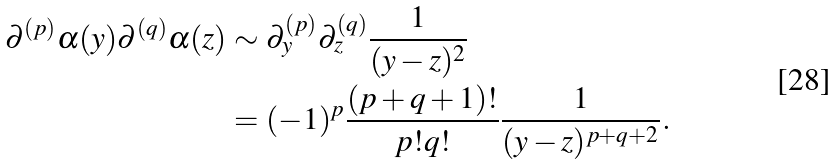<formula> <loc_0><loc_0><loc_500><loc_500>\partial ^ { ( p ) } \alpha ( y ) \partial ^ { ( q ) } \alpha ( z ) & \sim \partial _ { y } ^ { ( p ) } \partial _ { z } ^ { ( q ) } \frac { 1 } { ( y - z ) ^ { 2 } } \\ & = ( - 1 ) ^ { p } \frac { ( p + q + 1 ) ! } { p ! q ! } \frac { 1 } { ( y - z ) ^ { p + q + 2 } } .</formula> 